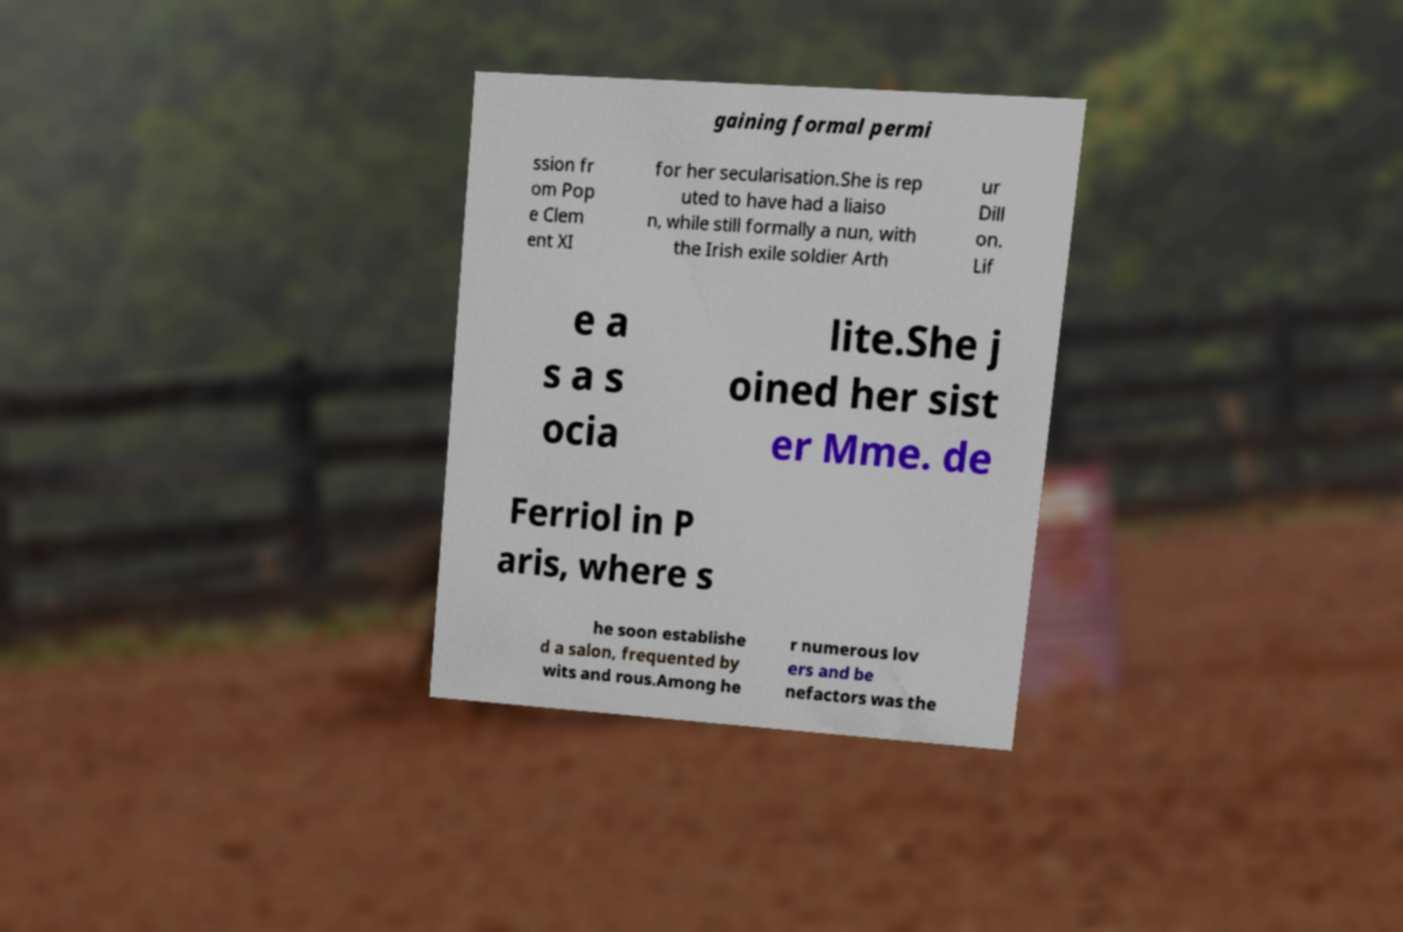I need the written content from this picture converted into text. Can you do that? gaining formal permi ssion fr om Pop e Clem ent XI for her secularisation.She is rep uted to have had a liaiso n, while still formally a nun, with the Irish exile soldier Arth ur Dill on. Lif e a s a s ocia lite.She j oined her sist er Mme. de Ferriol in P aris, where s he soon establishe d a salon, frequented by wits and rous.Among he r numerous lov ers and be nefactors was the 